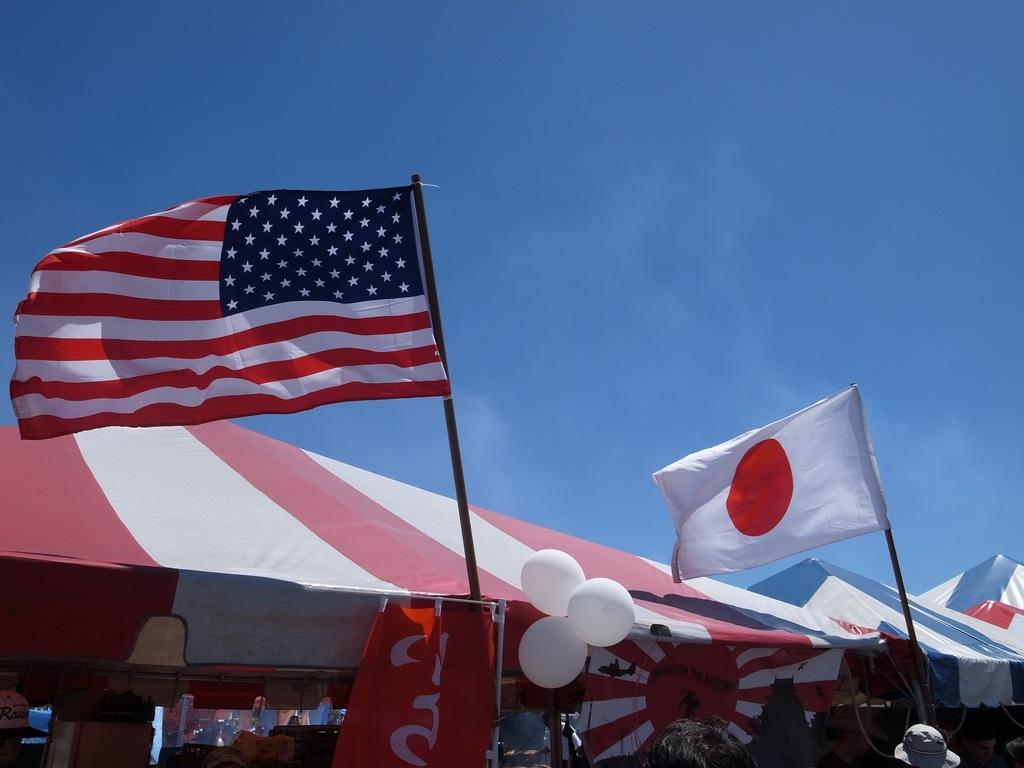What type of temporary structures are visible in the image? There are canopy tents in the image. What are the flags attached to in the image? The flags are attached to poles in the image. What decorative items can be seen in the image? There are balloons in the image. Who is present in the image? There is a group of people in the image. What can be seen in the background of the image? The sky is visible in the background of the image. What type of cakes are being served to the people in the image? There is no mention of cakes in the image; it features canopy tents, flags, balloons, and a group of people. What is the group of people afraid of in the image? There is no indication of fear in the image; the group of people is simply present. 